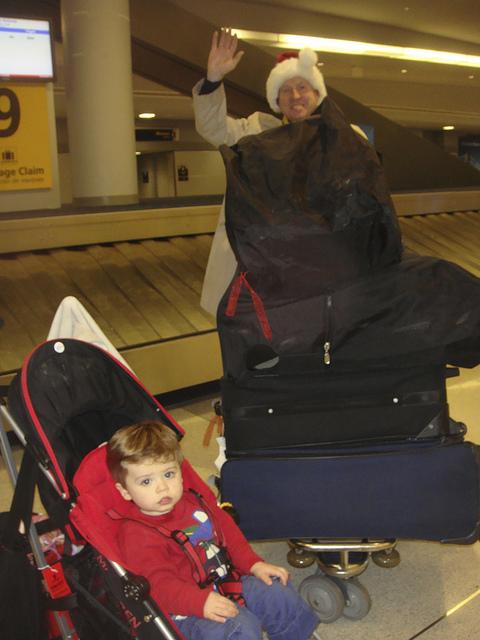Is the child sitting in a stroller?
Give a very brief answer. Yes. What color is the toddlers shirt?
Concise answer only. Red. Are these people at an airport?
Quick response, please. Yes. 